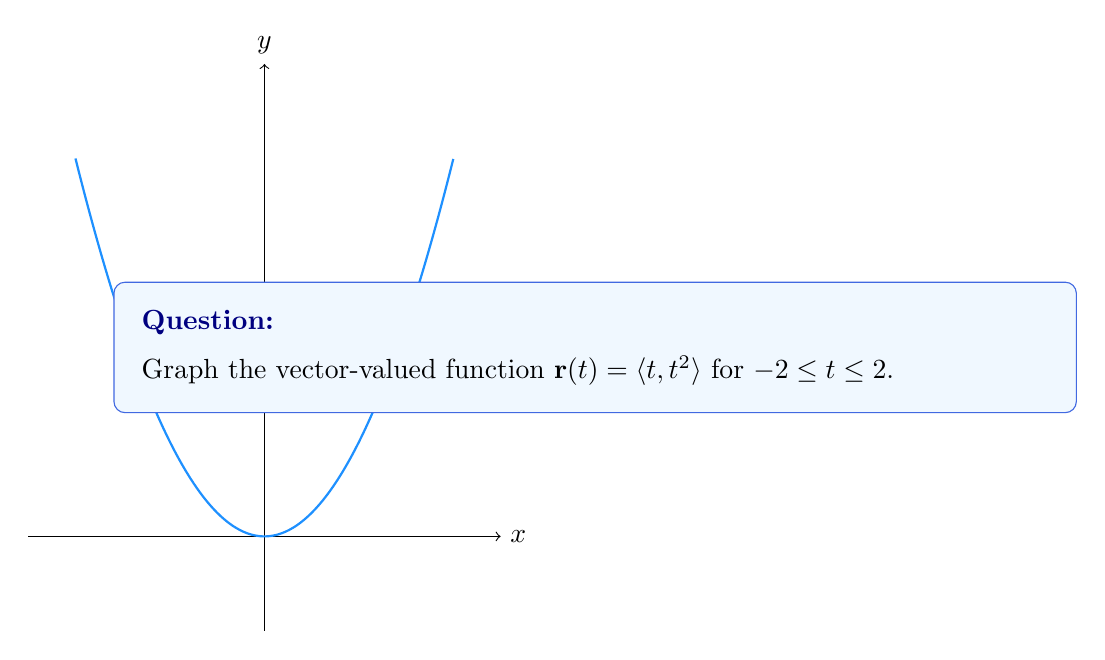Could you help me with this problem? To graph the vector-valued function $\mathbf{r}(t) = \langle t, t^2 \rangle$, we need to:

1. Understand what the function means:
   - The x-coordinate is given by $t$
   - The y-coordinate is given by $t^2$

2. Choose some values of $t$ in the given range $-2 \leq t \leq 2$:
   - When $t = -2$: $\mathbf{r}(-2) = \langle -2, (-2)^2 \rangle = \langle -2, 4 \rangle$
   - When $t = -1$: $\mathbf{r}(-1) = \langle -1, (-1)^2 \rangle = \langle -1, 1 \rangle$
   - When $t = 0$: $\mathbf{r}(0) = \langle 0, 0^2 \rangle = \langle 0, 0 \rangle$
   - When $t = 1$: $\mathbf{r}(1) = \langle 1, 1^2 \rangle = \langle 1, 1 \rangle$
   - When $t = 2$: $\mathbf{r}(2) = \langle 2, 2^2 \rangle = \langle 2, 4 \rangle$

3. Plot these points on a coordinate plane.

4. Connect the points with a smooth curve.

The resulting graph is a parabola opening upward, with its vertex at the origin (0,0).
Answer: Upward-opening parabola with vertex at (0,0) 